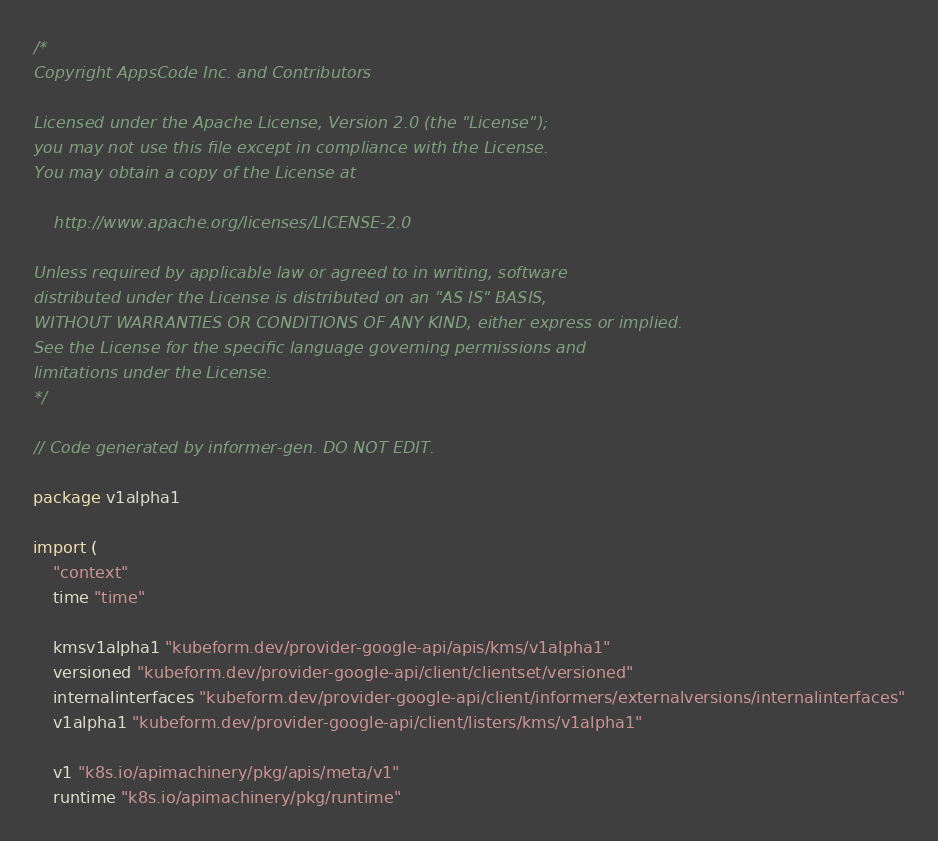Convert code to text. <code><loc_0><loc_0><loc_500><loc_500><_Go_>/*
Copyright AppsCode Inc. and Contributors

Licensed under the Apache License, Version 2.0 (the "License");
you may not use this file except in compliance with the License.
You may obtain a copy of the License at

    http://www.apache.org/licenses/LICENSE-2.0

Unless required by applicable law or agreed to in writing, software
distributed under the License is distributed on an "AS IS" BASIS,
WITHOUT WARRANTIES OR CONDITIONS OF ANY KIND, either express or implied.
See the License for the specific language governing permissions and
limitations under the License.
*/

// Code generated by informer-gen. DO NOT EDIT.

package v1alpha1

import (
	"context"
	time "time"

	kmsv1alpha1 "kubeform.dev/provider-google-api/apis/kms/v1alpha1"
	versioned "kubeform.dev/provider-google-api/client/clientset/versioned"
	internalinterfaces "kubeform.dev/provider-google-api/client/informers/externalversions/internalinterfaces"
	v1alpha1 "kubeform.dev/provider-google-api/client/listers/kms/v1alpha1"

	v1 "k8s.io/apimachinery/pkg/apis/meta/v1"
	runtime "k8s.io/apimachinery/pkg/runtime"</code> 